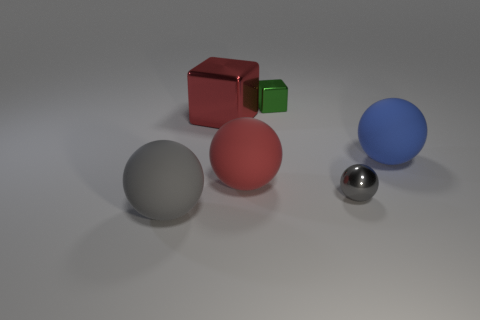The green metallic thing has what size? The green object, which appears to be a small cube in comparison to the surrounding shapes, would be classified as small in size; it's distinctly smaller than the red cube beside it. 